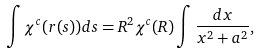Convert formula to latex. <formula><loc_0><loc_0><loc_500><loc_500>\int \chi ^ { c } ( r ( s ) ) d s = R ^ { 2 } \chi ^ { c } ( R ) \int \frac { d x } { x ^ { 2 } + a ^ { 2 } } ,</formula> 